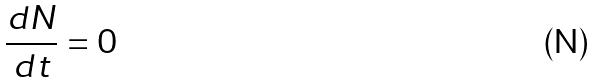Convert formula to latex. <formula><loc_0><loc_0><loc_500><loc_500>\frac { d N } { d t } = 0</formula> 